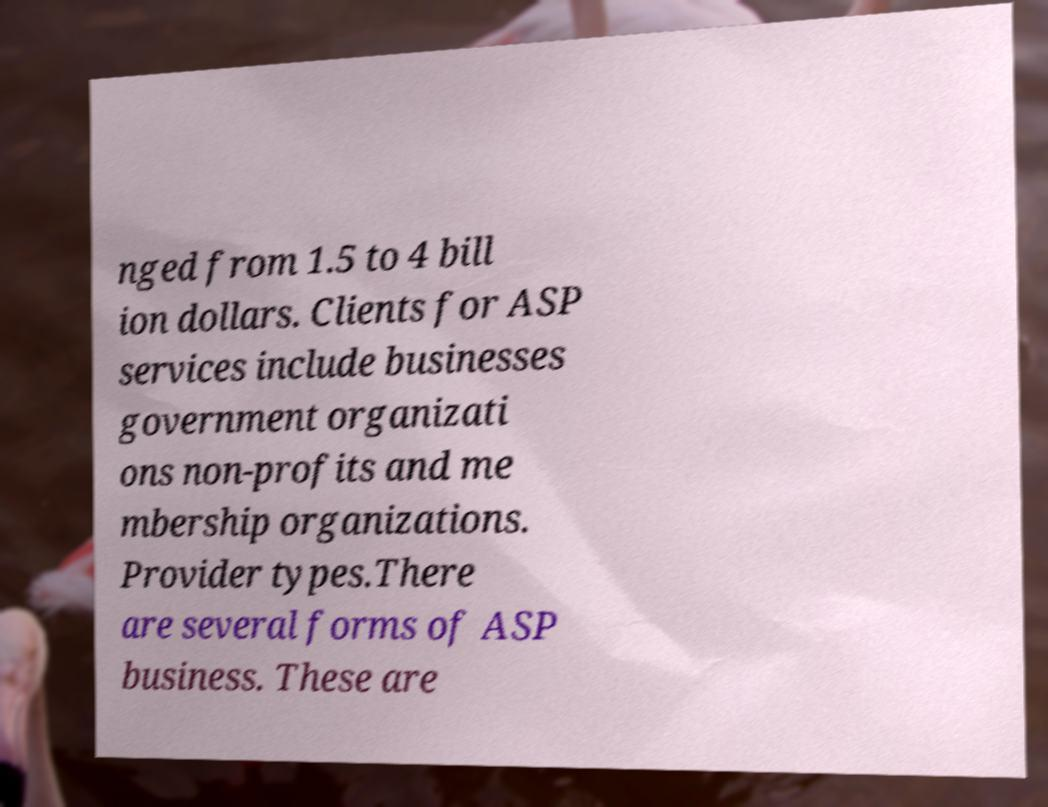Can you accurately transcribe the text from the provided image for me? nged from 1.5 to 4 bill ion dollars. Clients for ASP services include businesses government organizati ons non-profits and me mbership organizations. Provider types.There are several forms of ASP business. These are 